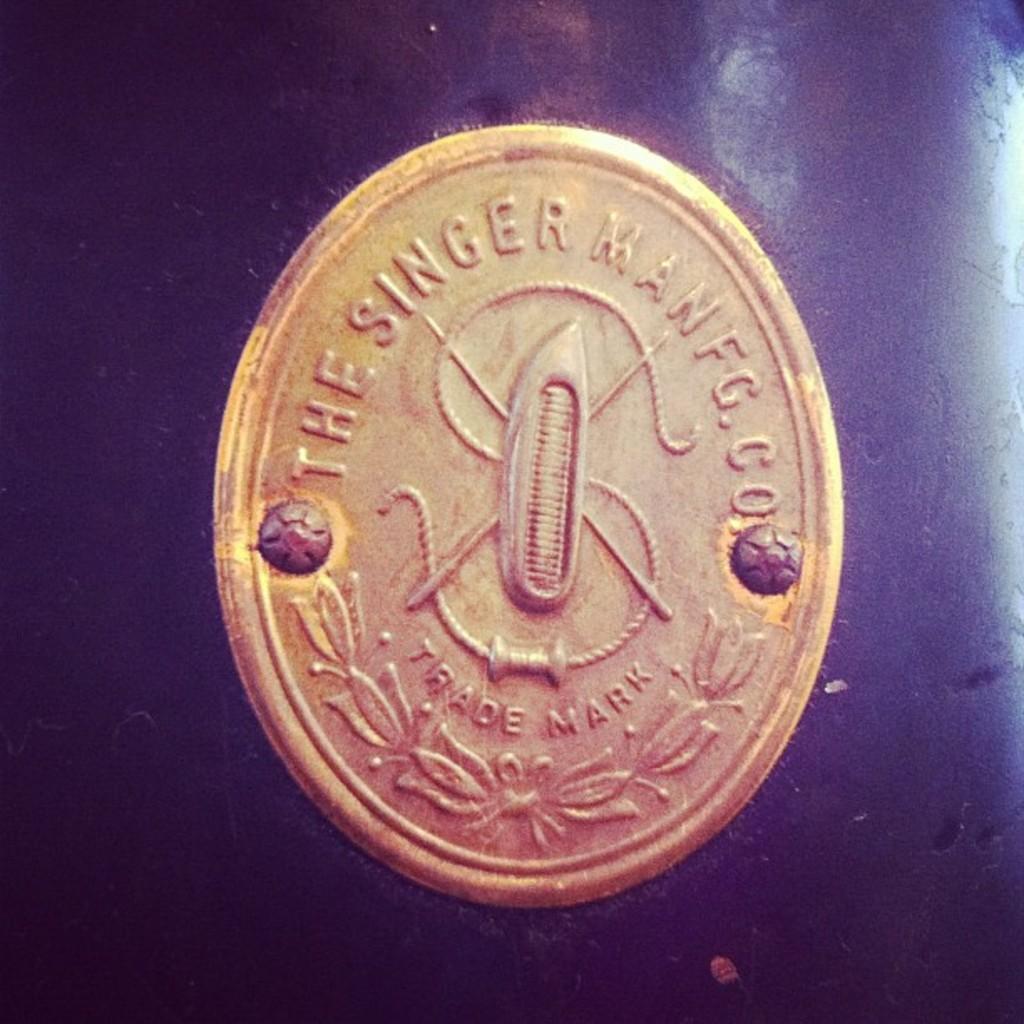What company does this belobg to?
Ensure brevity in your answer.  The singer manfg. co. What type of mark is on the coin?
Your response must be concise. Trade. 